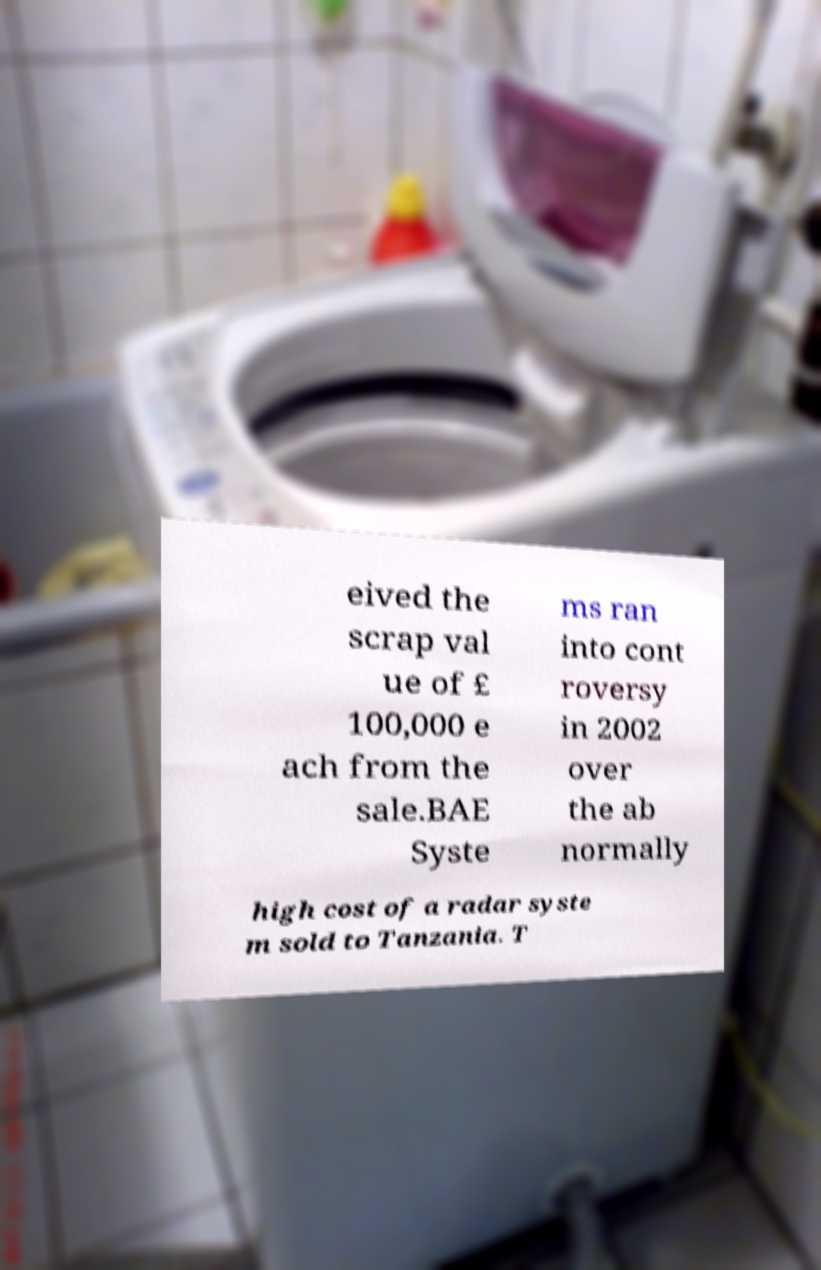Could you extract and type out the text from this image? eived the scrap val ue of £ 100,000 e ach from the sale.BAE Syste ms ran into cont roversy in 2002 over the ab normally high cost of a radar syste m sold to Tanzania. T 